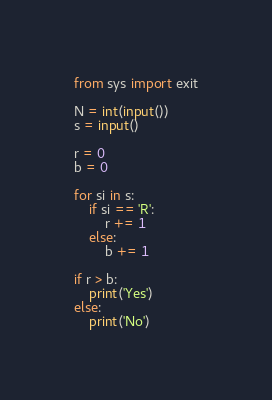<code> <loc_0><loc_0><loc_500><loc_500><_Python_>from sys import exit

N = int(input())
s = input()

r = 0
b = 0

for si in s:
    if si == 'R':
        r += 1
    else:
        b += 1

if r > b:
    print('Yes')
else:
    print('No')
</code> 